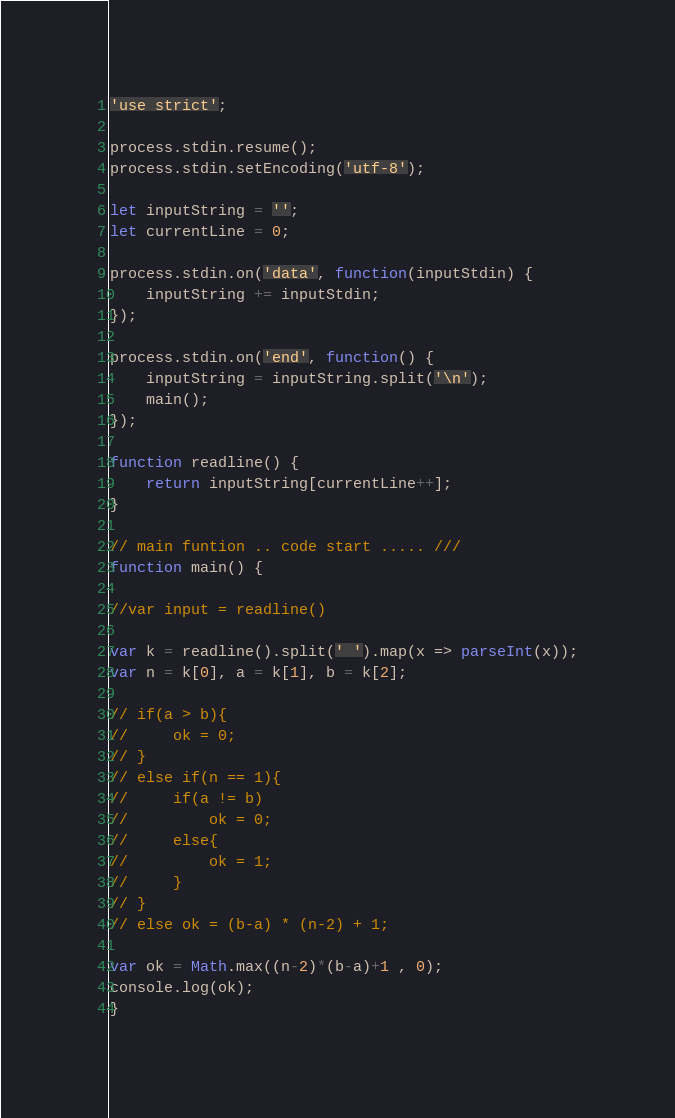<code> <loc_0><loc_0><loc_500><loc_500><_JavaScript_>'use strict';
 
process.stdin.resume();
process.stdin.setEncoding('utf-8');
 
let inputString = '';
let currentLine = 0;
 
process.stdin.on('data', function(inputStdin) {
    inputString += inputStdin;
});
 
process.stdin.on('end', function() {
    inputString = inputString.split('\n');
    main();
});
 
function readline() {
    return inputString[currentLine++];
}
 
// main funtion .. code start ..... ///
function main() {
 
//var input = readline()

var k = readline().split(' ').map(x => parseInt(x));
var n = k[0], a = k[1], b = k[2];

// if(a > b){
//     ok = 0;
// } 
// else if(n == 1){
//     if(a != b)
//         ok = 0;
//     else{
//         ok = 1;
//     }
// }
// else ok = (b-a) * (n-2) + 1;

var ok = Math.max((n-2)*(b-a)+1 , 0);
console.log(ok);
}</code> 